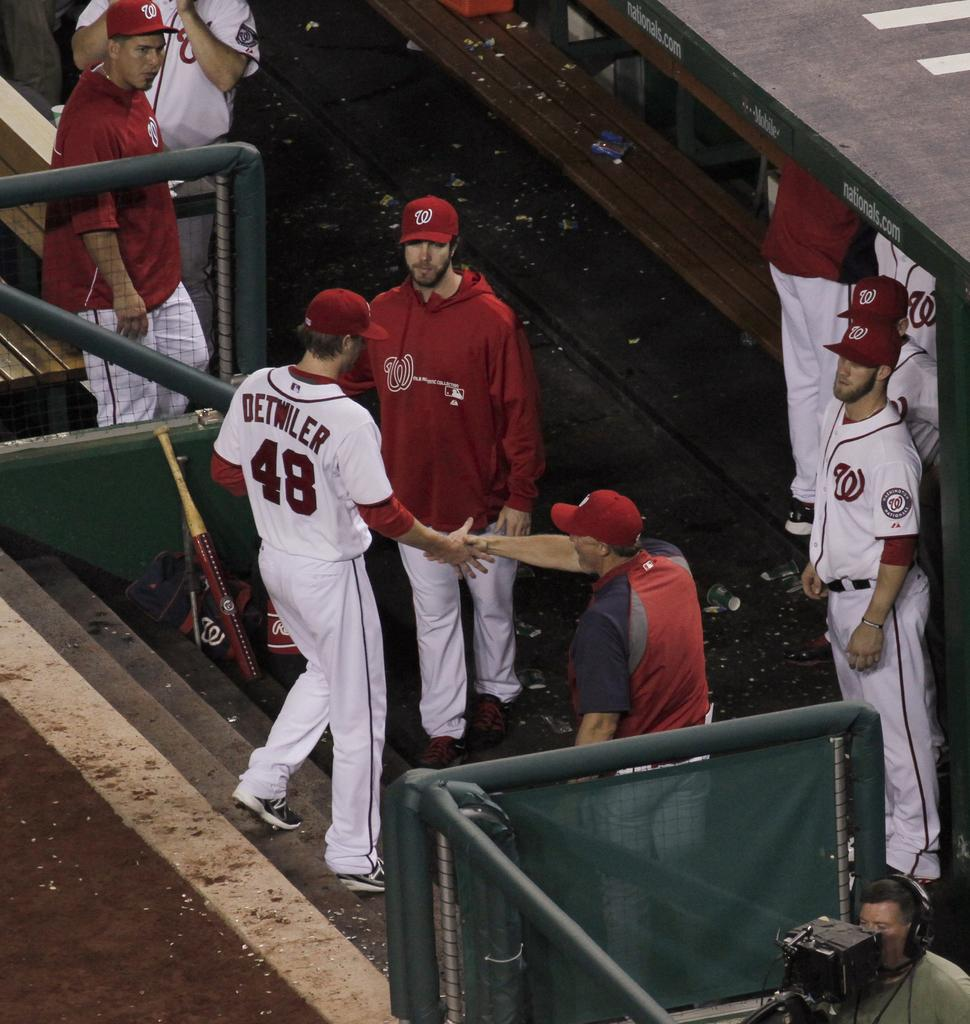<image>
Present a compact description of the photo's key features. A baseball player named Detwiler is walking down steps toward his team. 